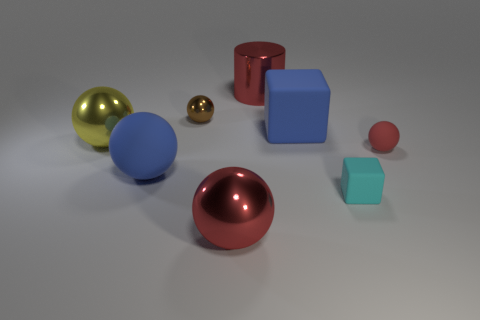There is a blue thing to the left of the tiny sphere that is left of the cyan rubber block; what is its material?
Ensure brevity in your answer.  Rubber. Are there fewer big yellow objects on the right side of the yellow object than things?
Keep it short and to the point. Yes. There is a cyan thing that is the same material as the big block; what is its shape?
Ensure brevity in your answer.  Cube. What number of other things are there of the same shape as the cyan rubber object?
Your answer should be compact. 1. What number of red objects are large cylinders or tiny cylinders?
Offer a terse response. 1. Does the small red object have the same shape as the yellow object?
Keep it short and to the point. Yes. There is a ball that is in front of the cyan matte block; is there a sphere behind it?
Give a very brief answer. Yes. Are there the same number of small brown shiny things in front of the large yellow ball and cyan things?
Your response must be concise. No. How many other things are the same size as the red shiny ball?
Your response must be concise. 4. Is the tiny cyan object in front of the cylinder made of the same material as the ball that is in front of the cyan rubber block?
Keep it short and to the point. No. 